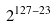<formula> <loc_0><loc_0><loc_500><loc_500>2 ^ { 1 2 7 - 2 3 }</formula> 